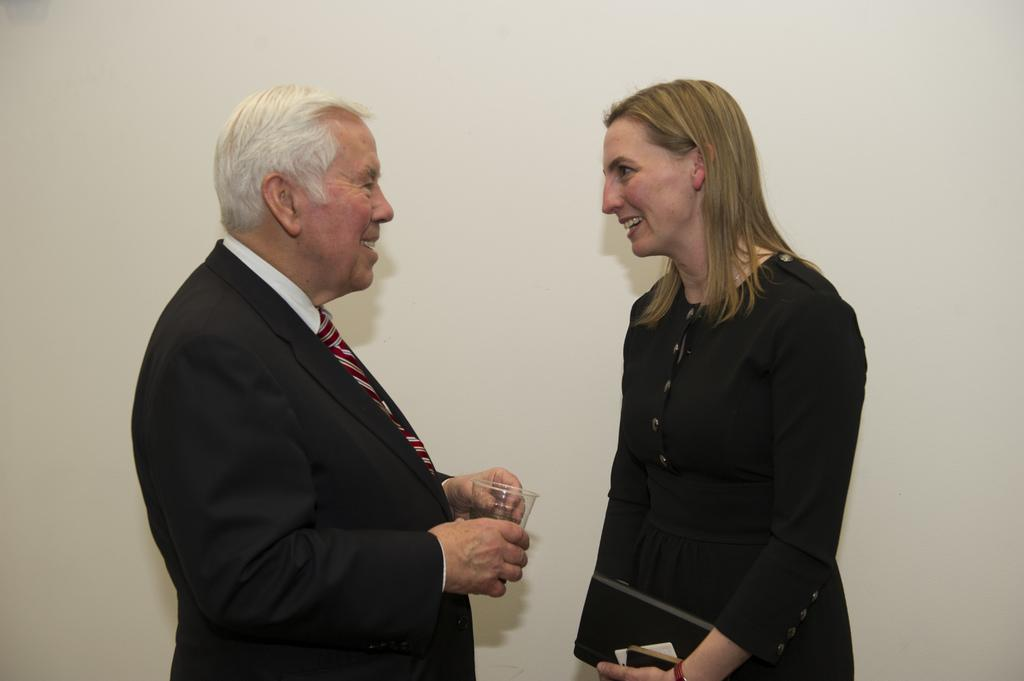Who or what can be seen in the image? There are people in the image. What are the people doing in the image? The people are holding objects in their hands. What is the color of the background in the image? The background of the image is white. What verse can be heard being recited in the image? There is no verse being recited in the image; it only shows people holding objects. Is there a plane visible in the image? No, there is no plane present in the image. 